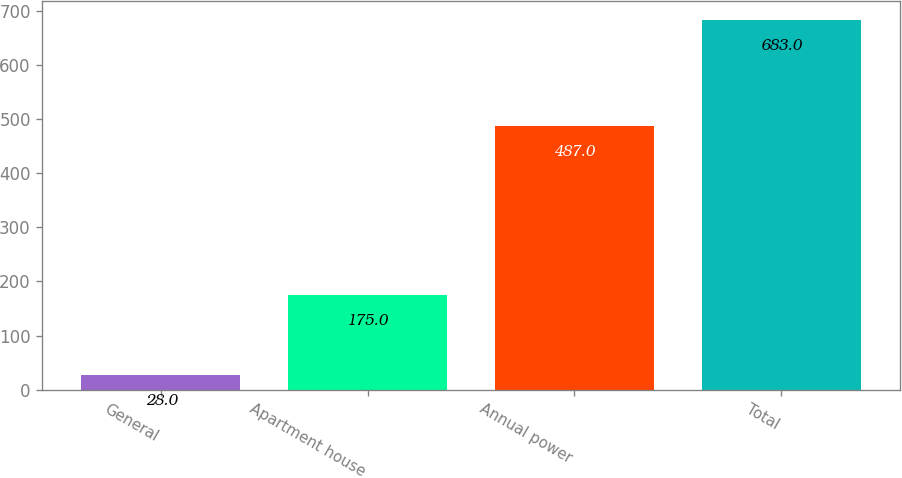Convert chart to OTSL. <chart><loc_0><loc_0><loc_500><loc_500><bar_chart><fcel>General<fcel>Apartment house<fcel>Annual power<fcel>Total<nl><fcel>28<fcel>175<fcel>487<fcel>683<nl></chart> 